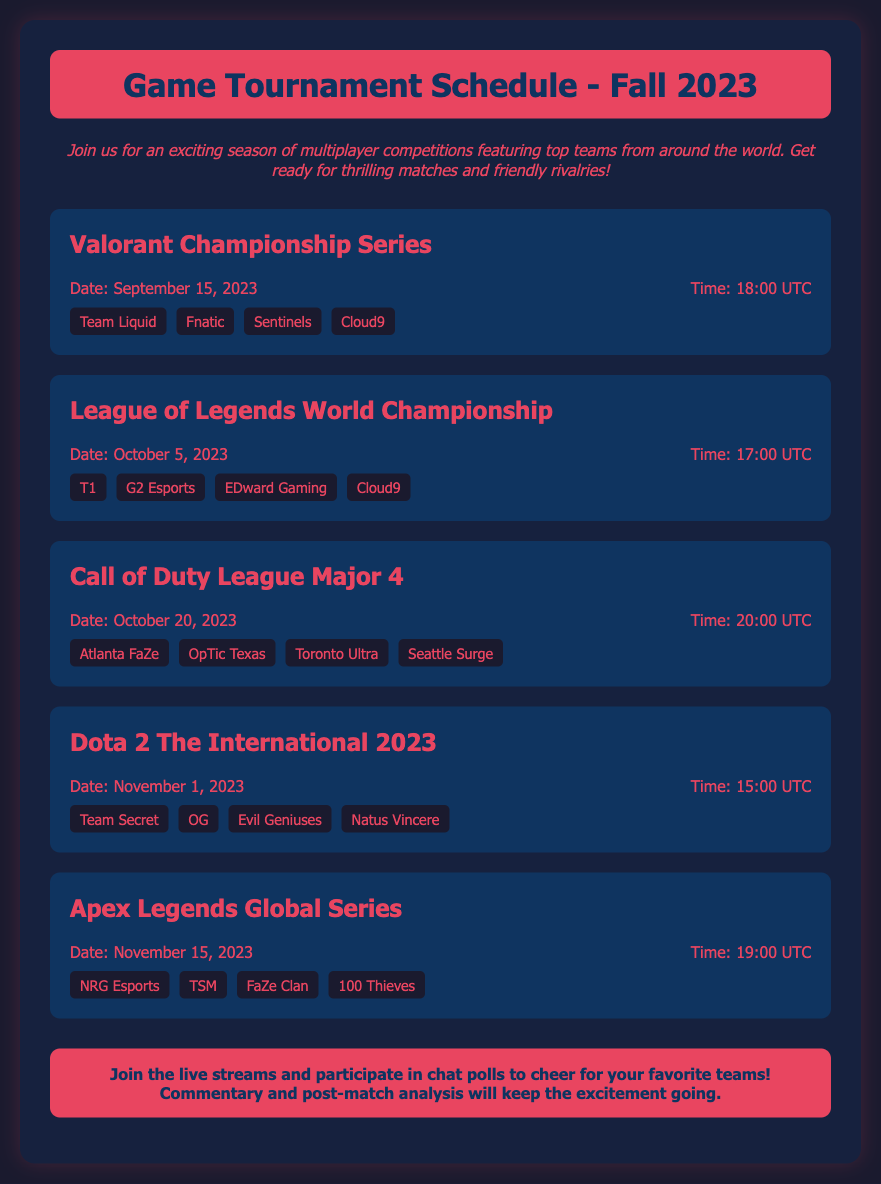What is the first tournament listed? The first tournament mentioned in the schedule is the "Valorant Championship Series."
Answer: Valorant Championship Series When is the League of Legends World Championship? The League of Legends World Championship is scheduled for October 5, 2023.
Answer: October 5, 2023 What time does the Dota 2 The International 2023 start? The Dota 2 The International 2023 is set to start at 15:00 UTC.
Answer: 15:00 UTC Which team is participating in both the Valorant Championship and League of Legends World Championships? The team that appears in both tournaments is "Cloud9."
Answer: Cloud9 How many teams are listed for the Call of Duty League Major 4? There are four teams listed for the Call of Duty League Major 4.
Answer: Four What is the date for the Apex Legends Global Series? The Apex Legends Global Series will take place on November 15, 2023.
Answer: November 15, 2023 What is the total number of tournaments listed in the schedule? The document lists a total of five tournaments.
Answer: Five What color is the background of the tournament details section? The background color of the tournament details section is "#0f3460."
Answer: #0f3460 